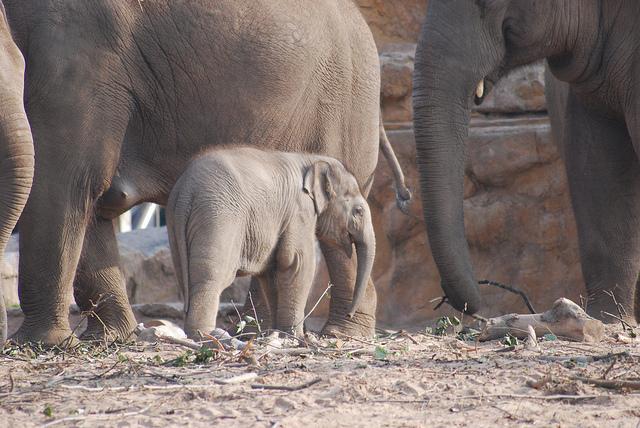Why is the baby elephant standing close to that particular adult elephant?
Give a very brief answer. It's parent. Is the baby elephant real?
Give a very brief answer. Yes. How many baby animals in this picture?
Write a very short answer. 1. How many elephants are there?
Keep it brief. 3. 